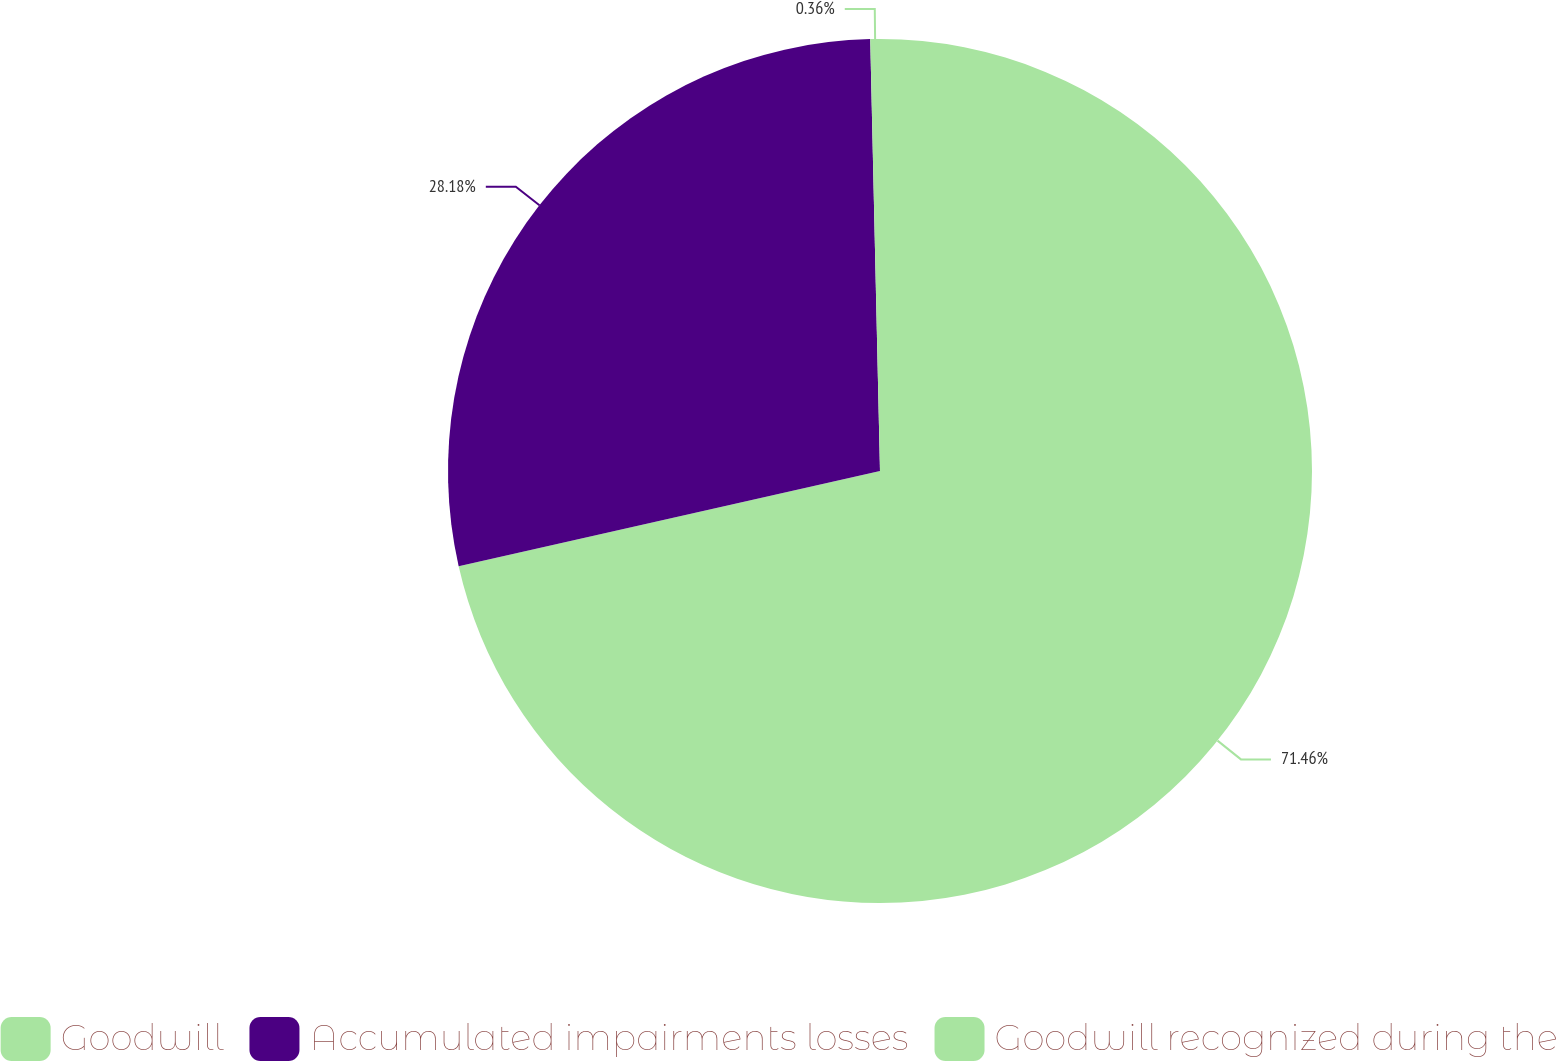Convert chart. <chart><loc_0><loc_0><loc_500><loc_500><pie_chart><fcel>Goodwill<fcel>Accumulated impairments losses<fcel>Goodwill recognized during the<nl><fcel>71.45%<fcel>28.18%<fcel>0.36%<nl></chart> 